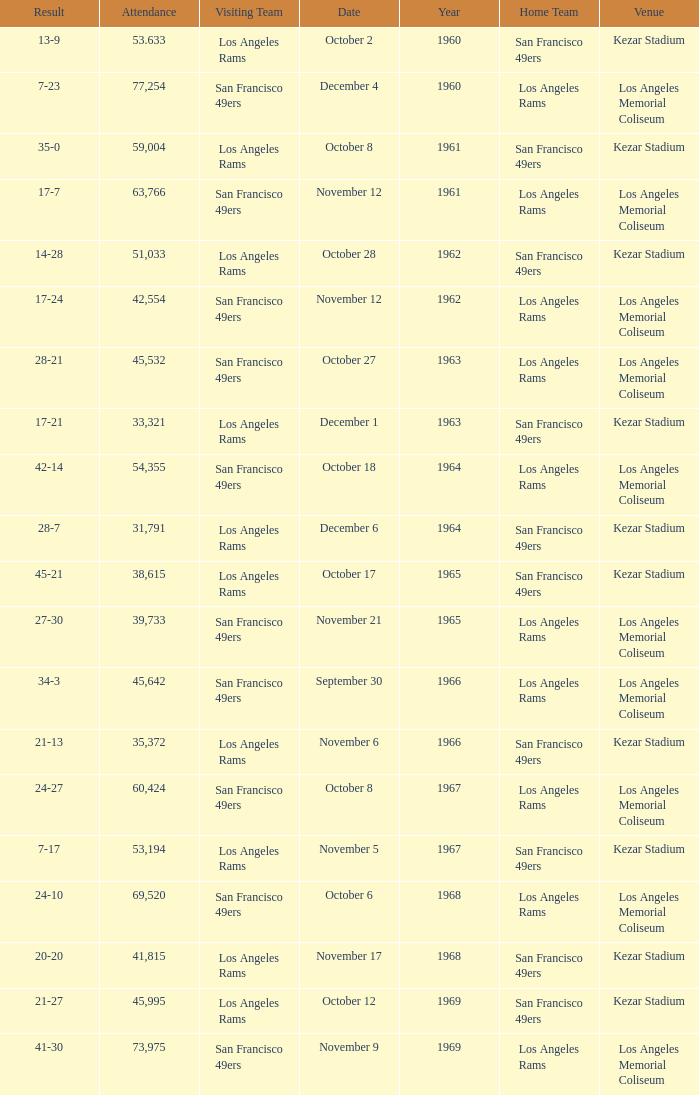When was the earliest year when the attendance was 77,254? 1960.0. 